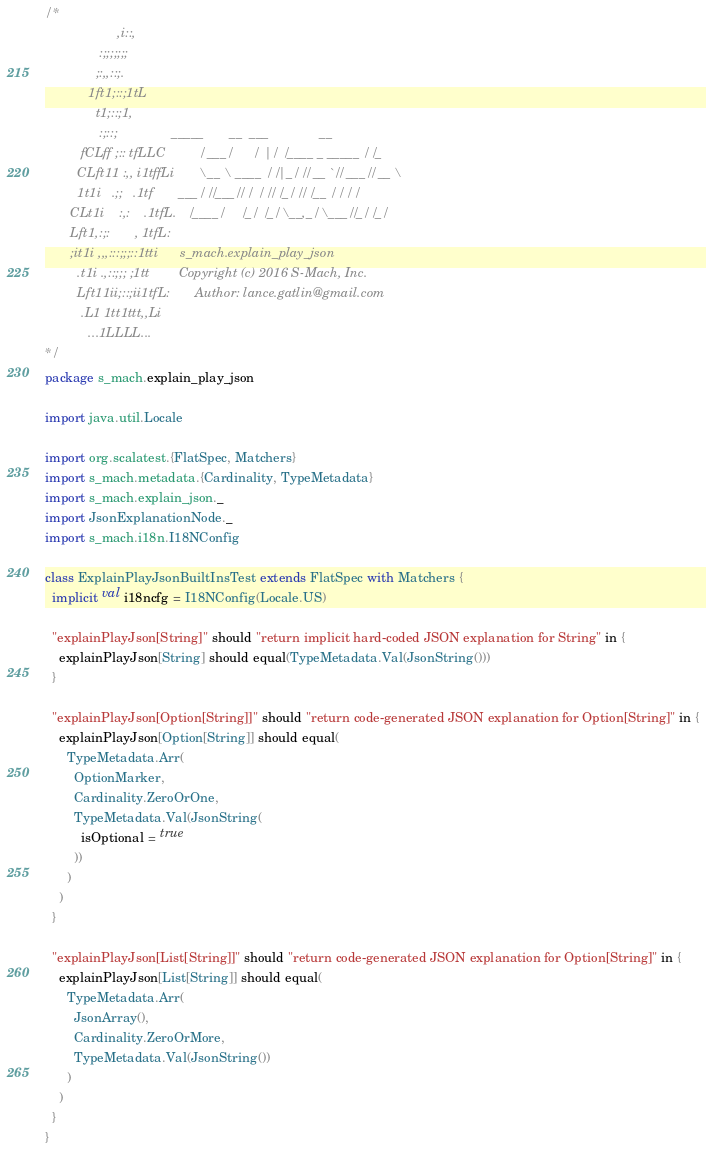Convert code to text. <code><loc_0><loc_0><loc_500><loc_500><_Scala_>/*
                    ,i::,
               :;;;;;;;
              ;:,,::;.
            1ft1;::;1tL
              t1;::;1,
               :;::;               _____       __  ___              __
          fCLff ;:: tfLLC         / ___/      /  |/  /____ _ _____ / /_
         CLft11 :,, i1tffLi       \__ \ ____ / /|_/ // __ `// ___// __ \
         1t1i   .;;   .1tf       ___/ //___// /  / // /_/ // /__ / / / /
       CLt1i    :,:    .1tfL.   /____/     /_/  /_/ \__,_/ \___//_/ /_/
       Lft1,:;:       , 1tfL:
       ;it1i ,,,:::;;;::1tti      s_mach.explain_play_json
         .t1i .,::;;; ;1tt        Copyright (c) 2016 S-Mach, Inc.
         Lft11ii;::;ii1tfL:       Author: lance.gatlin@gmail.com
          .L1 1tt1ttt,,Li
            ...1LLLL...
*/
package s_mach.explain_play_json

import java.util.Locale

import org.scalatest.{FlatSpec, Matchers}
import s_mach.metadata.{Cardinality, TypeMetadata}
import s_mach.explain_json._
import JsonExplanationNode._
import s_mach.i18n.I18NConfig

class ExplainPlayJsonBuiltInsTest extends FlatSpec with Matchers {
  implicit val i18ncfg = I18NConfig(Locale.US)

  "explainPlayJson[String]" should "return implicit hard-coded JSON explanation for String" in {
    explainPlayJson[String] should equal(TypeMetadata.Val(JsonString()))
  }

  "explainPlayJson[Option[String]]" should "return code-generated JSON explanation for Option[String]" in {
    explainPlayJson[Option[String]] should equal(
      TypeMetadata.Arr(
        OptionMarker,
        Cardinality.ZeroOrOne,
        TypeMetadata.Val(JsonString(
          isOptional = true
        ))
      )
    )
  }

  "explainPlayJson[List[String]]" should "return code-generated JSON explanation for Option[String]" in {
    explainPlayJson[List[String]] should equal(
      TypeMetadata.Arr(
        JsonArray(),
        Cardinality.ZeroOrMore,
        TypeMetadata.Val(JsonString())
      )
    )
  }
}
</code> 